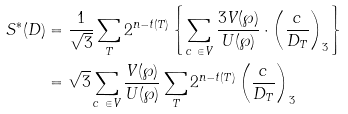Convert formula to latex. <formula><loc_0><loc_0><loc_500><loc_500>S ^ { * } ( D ) & = \frac { 1 } { \sqrt { 3 } } \sum _ { T } 2 ^ { n - t ( T ) } \left \{ \sum _ { c \ \in V } \frac { 3 V ( \wp ) } { U ( \wp ) } \cdot \left ( \frac { c } { D _ { T } } \right ) _ { 3 } \right \} \\ & = \sqrt { 3 } \sum _ { c \ \in V } \frac { V ( \wp ) } { U ( \wp ) } \sum _ { T } 2 ^ { n - t ( T ) } \left ( \frac { c } { D _ { T } } \right ) _ { 3 }</formula> 